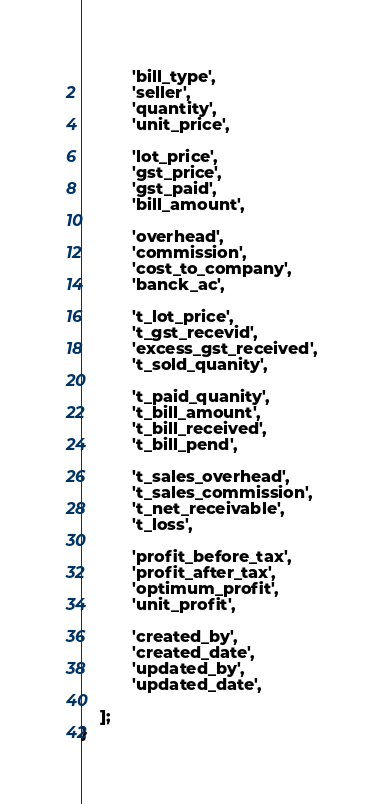Convert code to text. <code><loc_0><loc_0><loc_500><loc_500><_PHP_>
           'bill_type',
           'seller',
           'quantity',
           'unit_price',

           'lot_price',
           'gst_price',
           'gst_paid',
           'bill_amount',

           'overhead',
           'commission',
           'cost_to_company',
           'banck_ac',

           't_lot_price',
           't_gst_recevid',
           'excess_gst_received',
           't_sold_quanity',

           't_paid_quanity',
           't_bill_amount',
           't_bill_received',
           't_bill_pend',

           't_sales_overhead',
           't_sales_commission',
           't_net_receivable',
           't_loss',

           'profit_before_tax',
           'profit_after_tax',
           'optimum_profit',
           'unit_profit',

           'created_by',
           'created_date',
           'updated_by',
           'updated_date',

    ];
}
</code> 